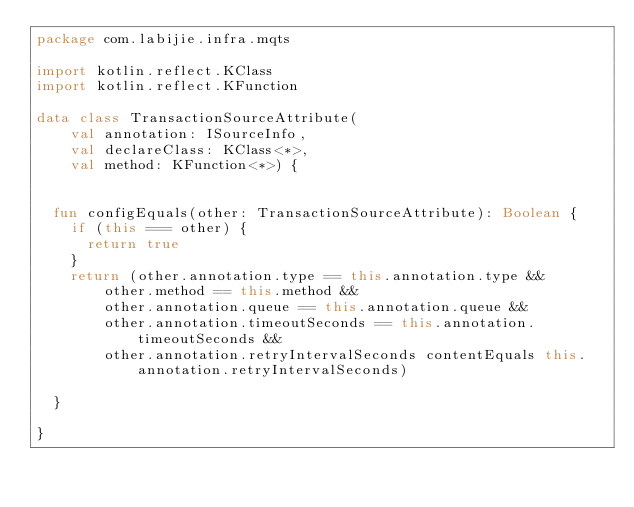<code> <loc_0><loc_0><loc_500><loc_500><_Kotlin_>package com.labijie.infra.mqts

import kotlin.reflect.KClass
import kotlin.reflect.KFunction

data class TransactionSourceAttribute(
    val annotation: ISourceInfo,
    val declareClass: KClass<*>,
    val method: KFunction<*>) {


  fun configEquals(other: TransactionSourceAttribute): Boolean {
    if (this === other) {
      return true
    }
    return (other.annotation.type == this.annotation.type &&
        other.method == this.method &&
        other.annotation.queue == this.annotation.queue &&
        other.annotation.timeoutSeconds == this.annotation.timeoutSeconds &&
        other.annotation.retryIntervalSeconds contentEquals this.annotation.retryIntervalSeconds)

  }

}</code> 